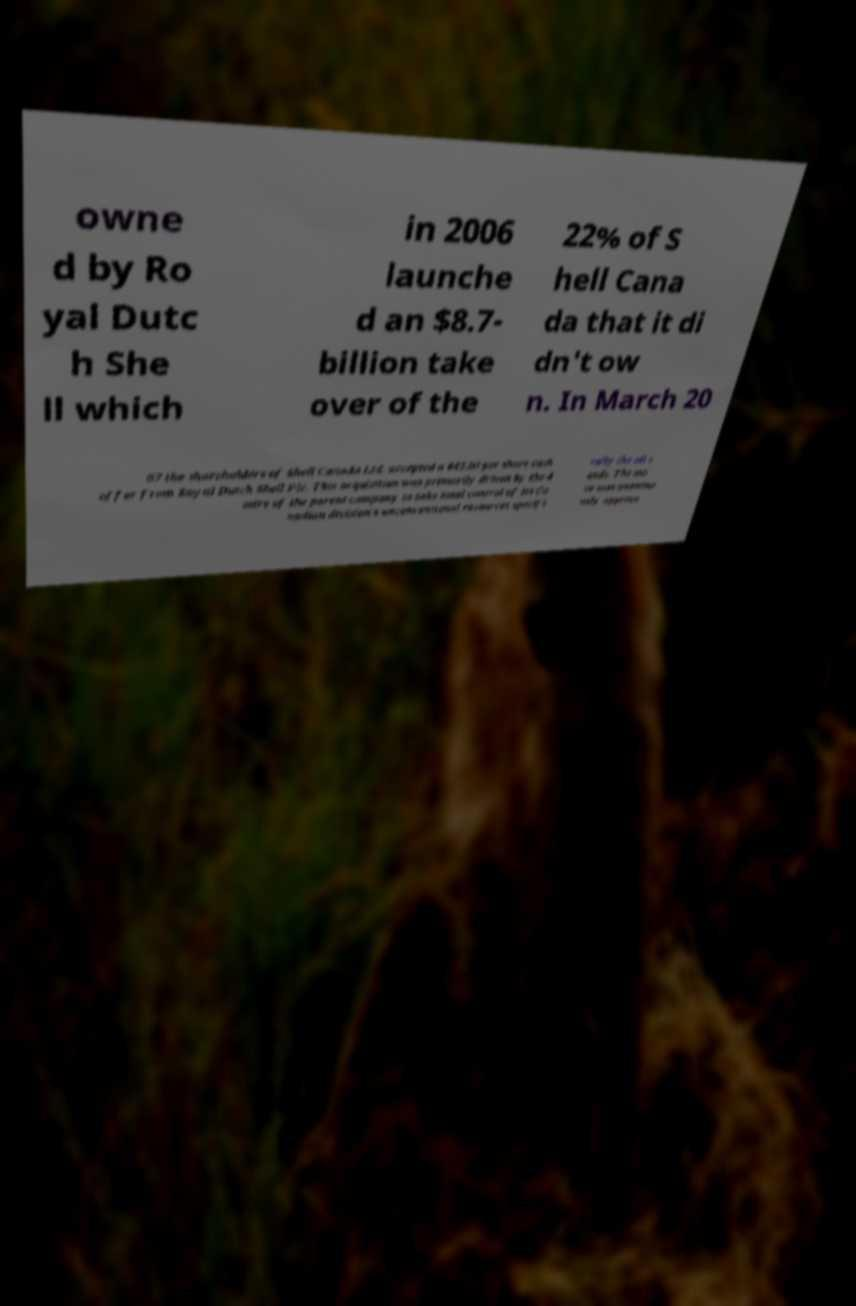Please read and relay the text visible in this image. What does it say? owne d by Ro yal Dutc h She ll which in 2006 launche d an $8.7- billion take over of the 22% of S hell Cana da that it di dn't ow n. In March 20 07 the shareholders of Shell Canada Ltd. accepted a $45.00 per share cash offer from Royal Dutch Shell Plc. This acquisition was primarily driven by the d esire of the parent company to take total control of its Ca nadian division's unconventional resources specifi cally the oil s ands. The mo ve was unanimo usly approve 